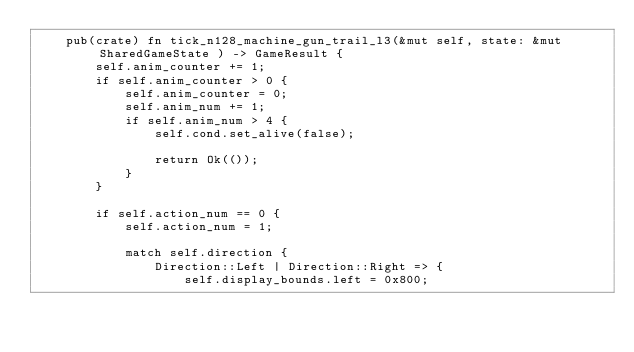<code> <loc_0><loc_0><loc_500><loc_500><_Rust_>    pub(crate) fn tick_n128_machine_gun_trail_l3(&mut self, state: &mut SharedGameState ) -> GameResult {
        self.anim_counter += 1;
        if self.anim_counter > 0 {
            self.anim_counter = 0;
            self.anim_num += 1;
            if self.anim_num > 4 {
                self.cond.set_alive(false);

                return Ok(());
            }
        }

        if self.action_num == 0 {
            self.action_num = 1;

            match self.direction {
                Direction::Left | Direction::Right => {
                    self.display_bounds.left = 0x800;</code> 